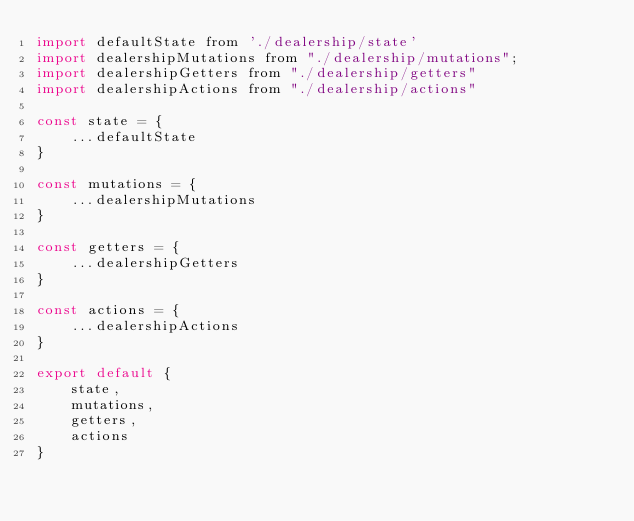Convert code to text. <code><loc_0><loc_0><loc_500><loc_500><_JavaScript_>import defaultState from './dealership/state'
import dealershipMutations from "./dealership/mutations";
import dealershipGetters from "./dealership/getters"
import dealershipActions from "./dealership/actions"

const state = {
    ...defaultState
}

const mutations = {
    ...dealershipMutations
}

const getters = {
    ...dealershipGetters
}

const actions = {
    ...dealershipActions
}

export default {
    state,
    mutations,
    getters,
    actions
}
</code> 